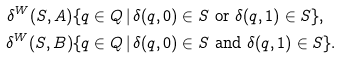Convert formula to latex. <formula><loc_0><loc_0><loc_500><loc_500>\delta ^ { W } ( S , A ) & \{ q \in Q \, | \, \delta ( q , 0 ) \in S \text { or } \delta ( q , 1 ) \in S \} , \\ \delta ^ { W } ( S , B ) & \{ q \in Q \, | \, \delta ( q , 0 ) \in S \text { and } \delta ( q , 1 ) \in S \} .</formula> 